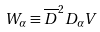Convert formula to latex. <formula><loc_0><loc_0><loc_500><loc_500>W _ { \alpha } \equiv \overline { D } ^ { 2 } D _ { \alpha } V</formula> 